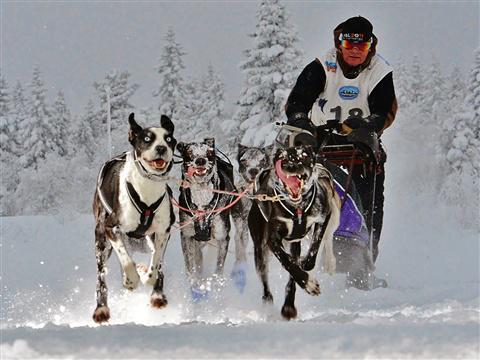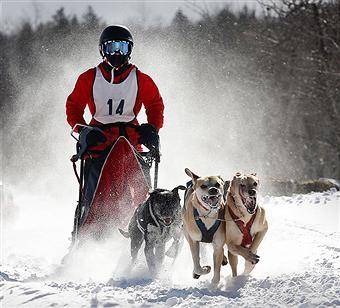The first image is the image on the left, the second image is the image on the right. Evaluate the accuracy of this statement regarding the images: "Each image shows a man in a numbered vest being pulled by a team of dogs moving forward.". Is it true? Answer yes or no. Yes. The first image is the image on the left, the second image is the image on the right. Analyze the images presented: Is the assertion "A dog is up on its hind legs." valid? Answer yes or no. No. 